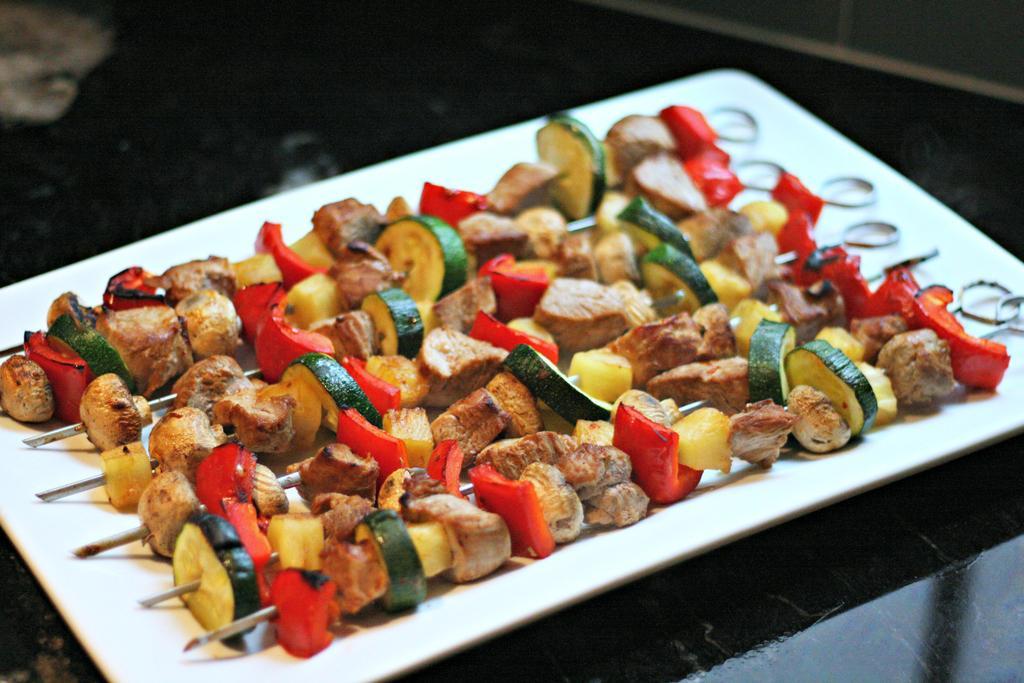Describe this image in one or two sentences. In the image there are veg barbeque sticks in a plate on a table. 